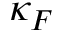<formula> <loc_0><loc_0><loc_500><loc_500>\kappa _ { F }</formula> 